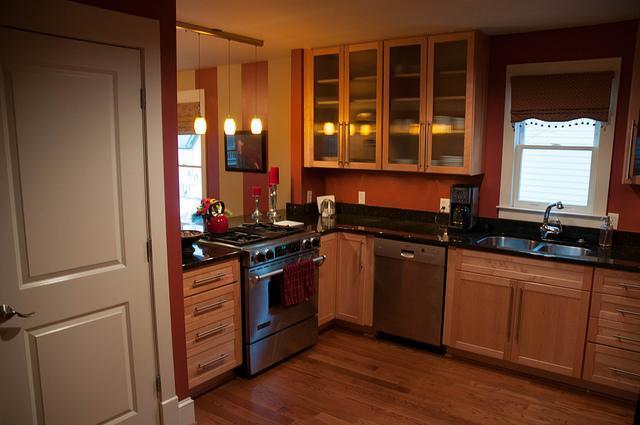How many ovens does this kitchen have?
Give a very brief answer. 1. How many people are in the water?
Give a very brief answer. 0. 